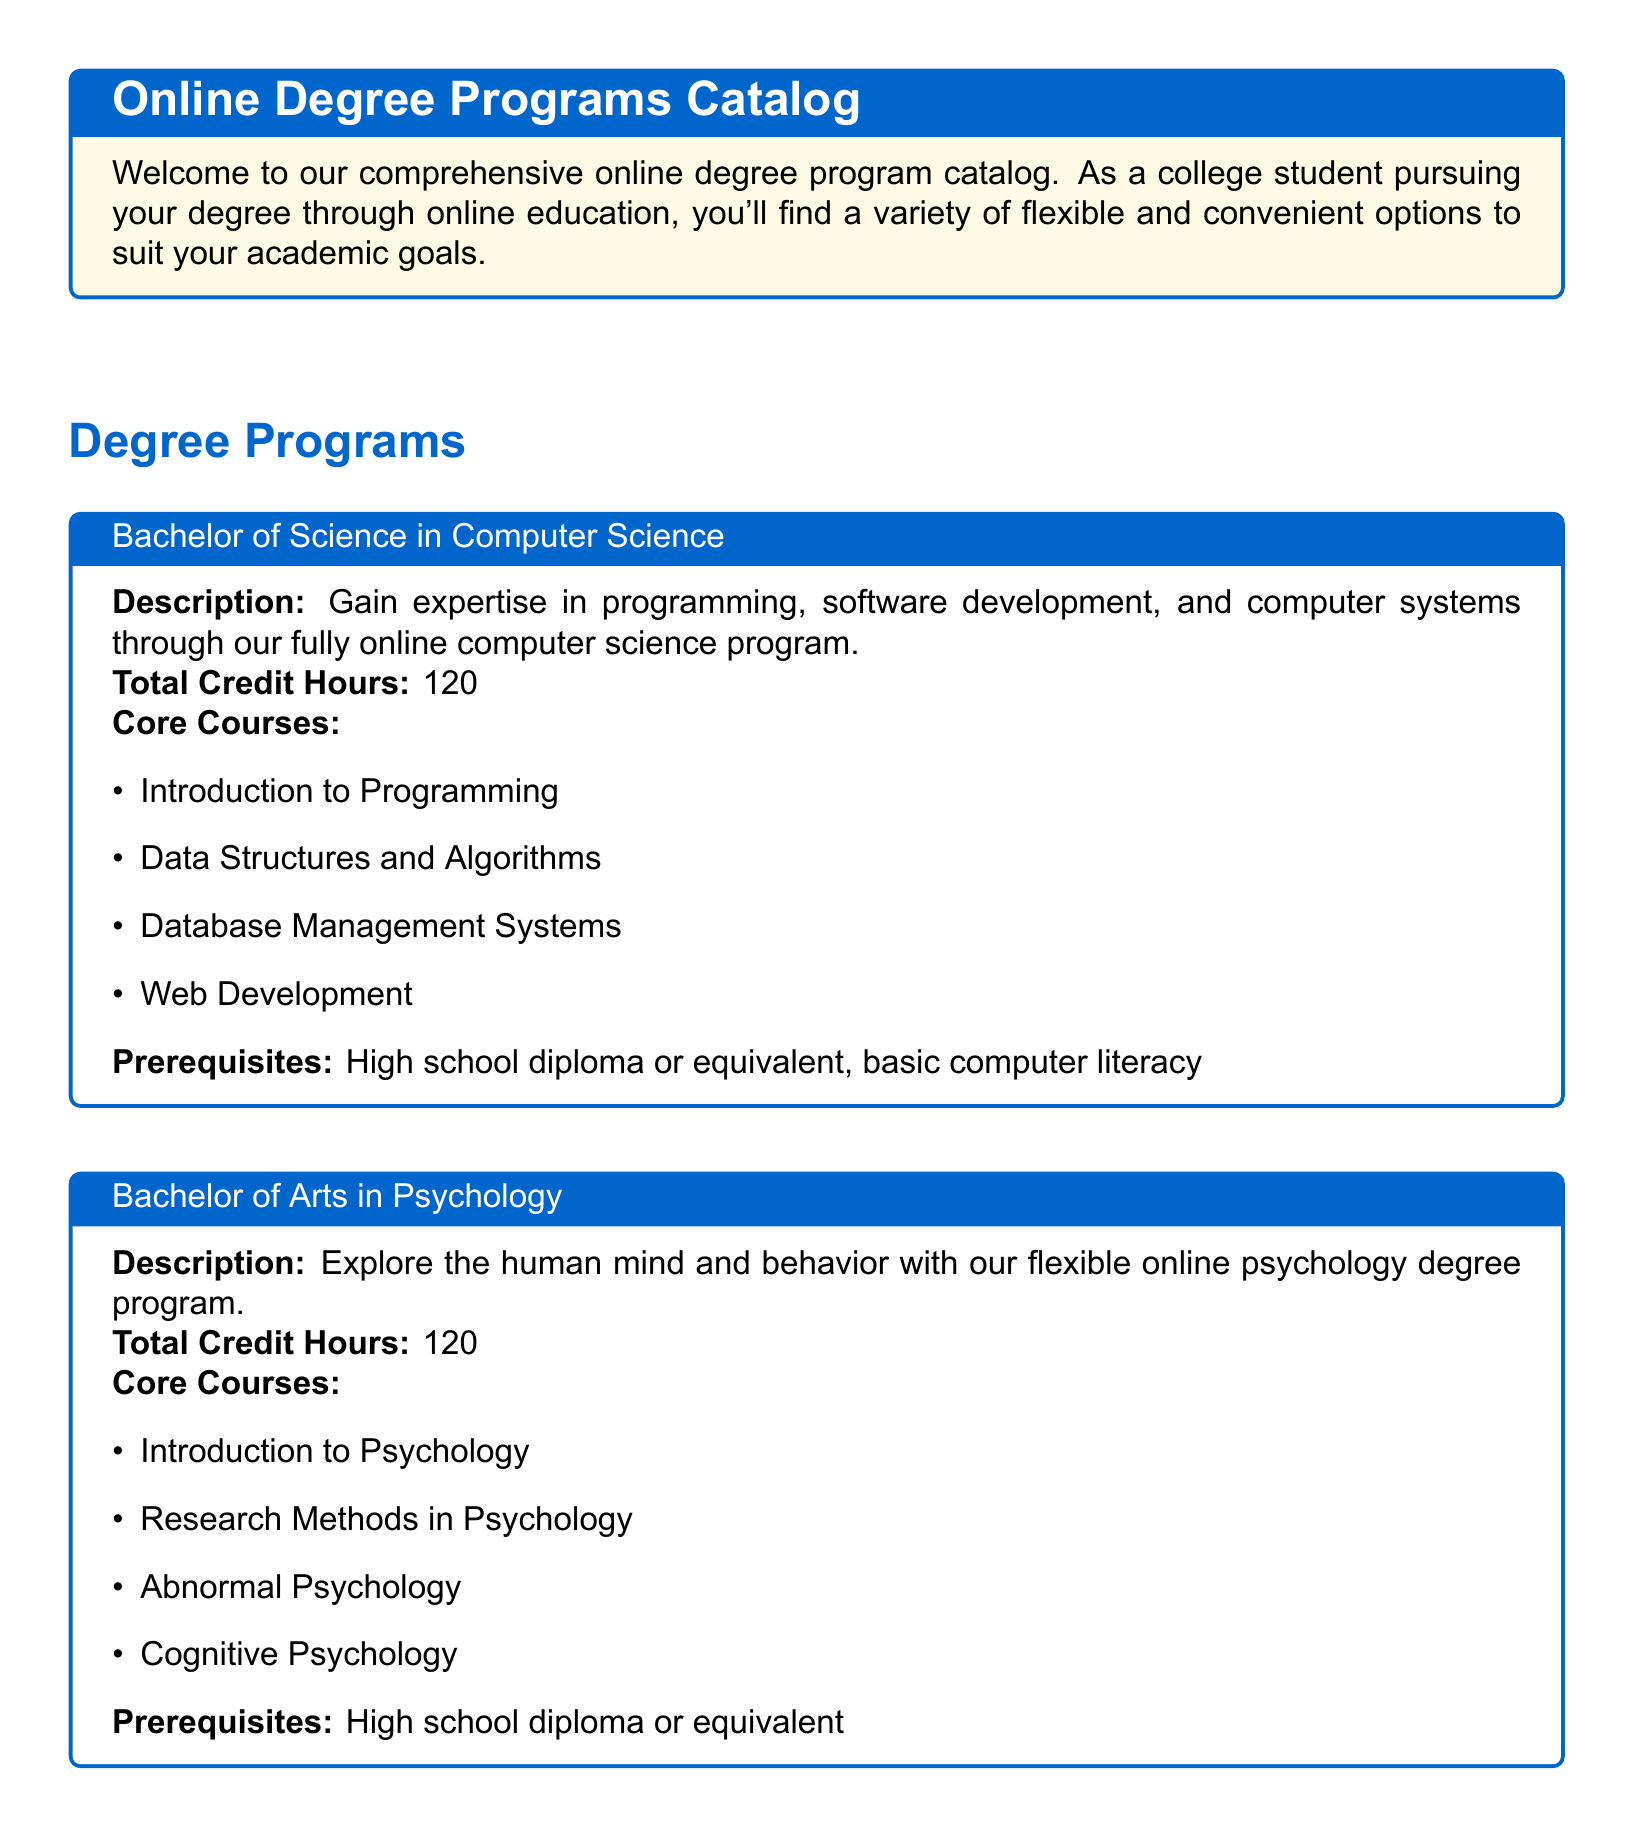What is the total credit hours for the Bachelor of Science in Computer Science? The total credit hours for the Bachelor of Science in Computer Science program is specified in the document.
Answer: 120 What course is included in the core courses of the Associate of Applied Science in Business Administration? The core courses are listed in the document, and one of them is mentioned for the Associate of Applied Science in Business Administration program.
Answer: Principles of Management What is a prerequisite for the Bachelor of Arts in Psychology? The document specifies requirements for entering the Bachelor of Arts in Psychology program, including prerequisites.
Answer: High school diploma or equivalent How many total credit hours are required for an Associate of Applied Science in Business Administration? The total credit hours can be found in the program description in the document.
Answer: 60 What type of support is offered to students according to the additional information section? The document outlines various support services available for students, emphasizing the academic support provided.
Answer: 24/7 tutoring services What is one of the technology requirements for online courses? The document specifies the necessary technology tools for students pursuing online courses.
Answer: Reliable internet connection How many core courses are listed for the Bachelor of Science in Computer Science? The number of core courses is implied by the list provided in the program description, which can be counted.
Answer: 4 What is the main focus of the Bachelor of Arts in Psychology program? This information is found in the description of the program listed in the online degree programs catalog.
Answer: Explore the human mind and behavior What step is involved in the enrollment process? The document provides a brief description regarding how to enroll in the online degree programs, indicating the application method.
Answer: Apply online through our user-friendly student portal 